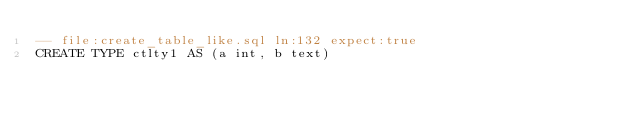<code> <loc_0><loc_0><loc_500><loc_500><_SQL_>-- file:create_table_like.sql ln:132 expect:true
CREATE TYPE ctlty1 AS (a int, b text)
</code> 